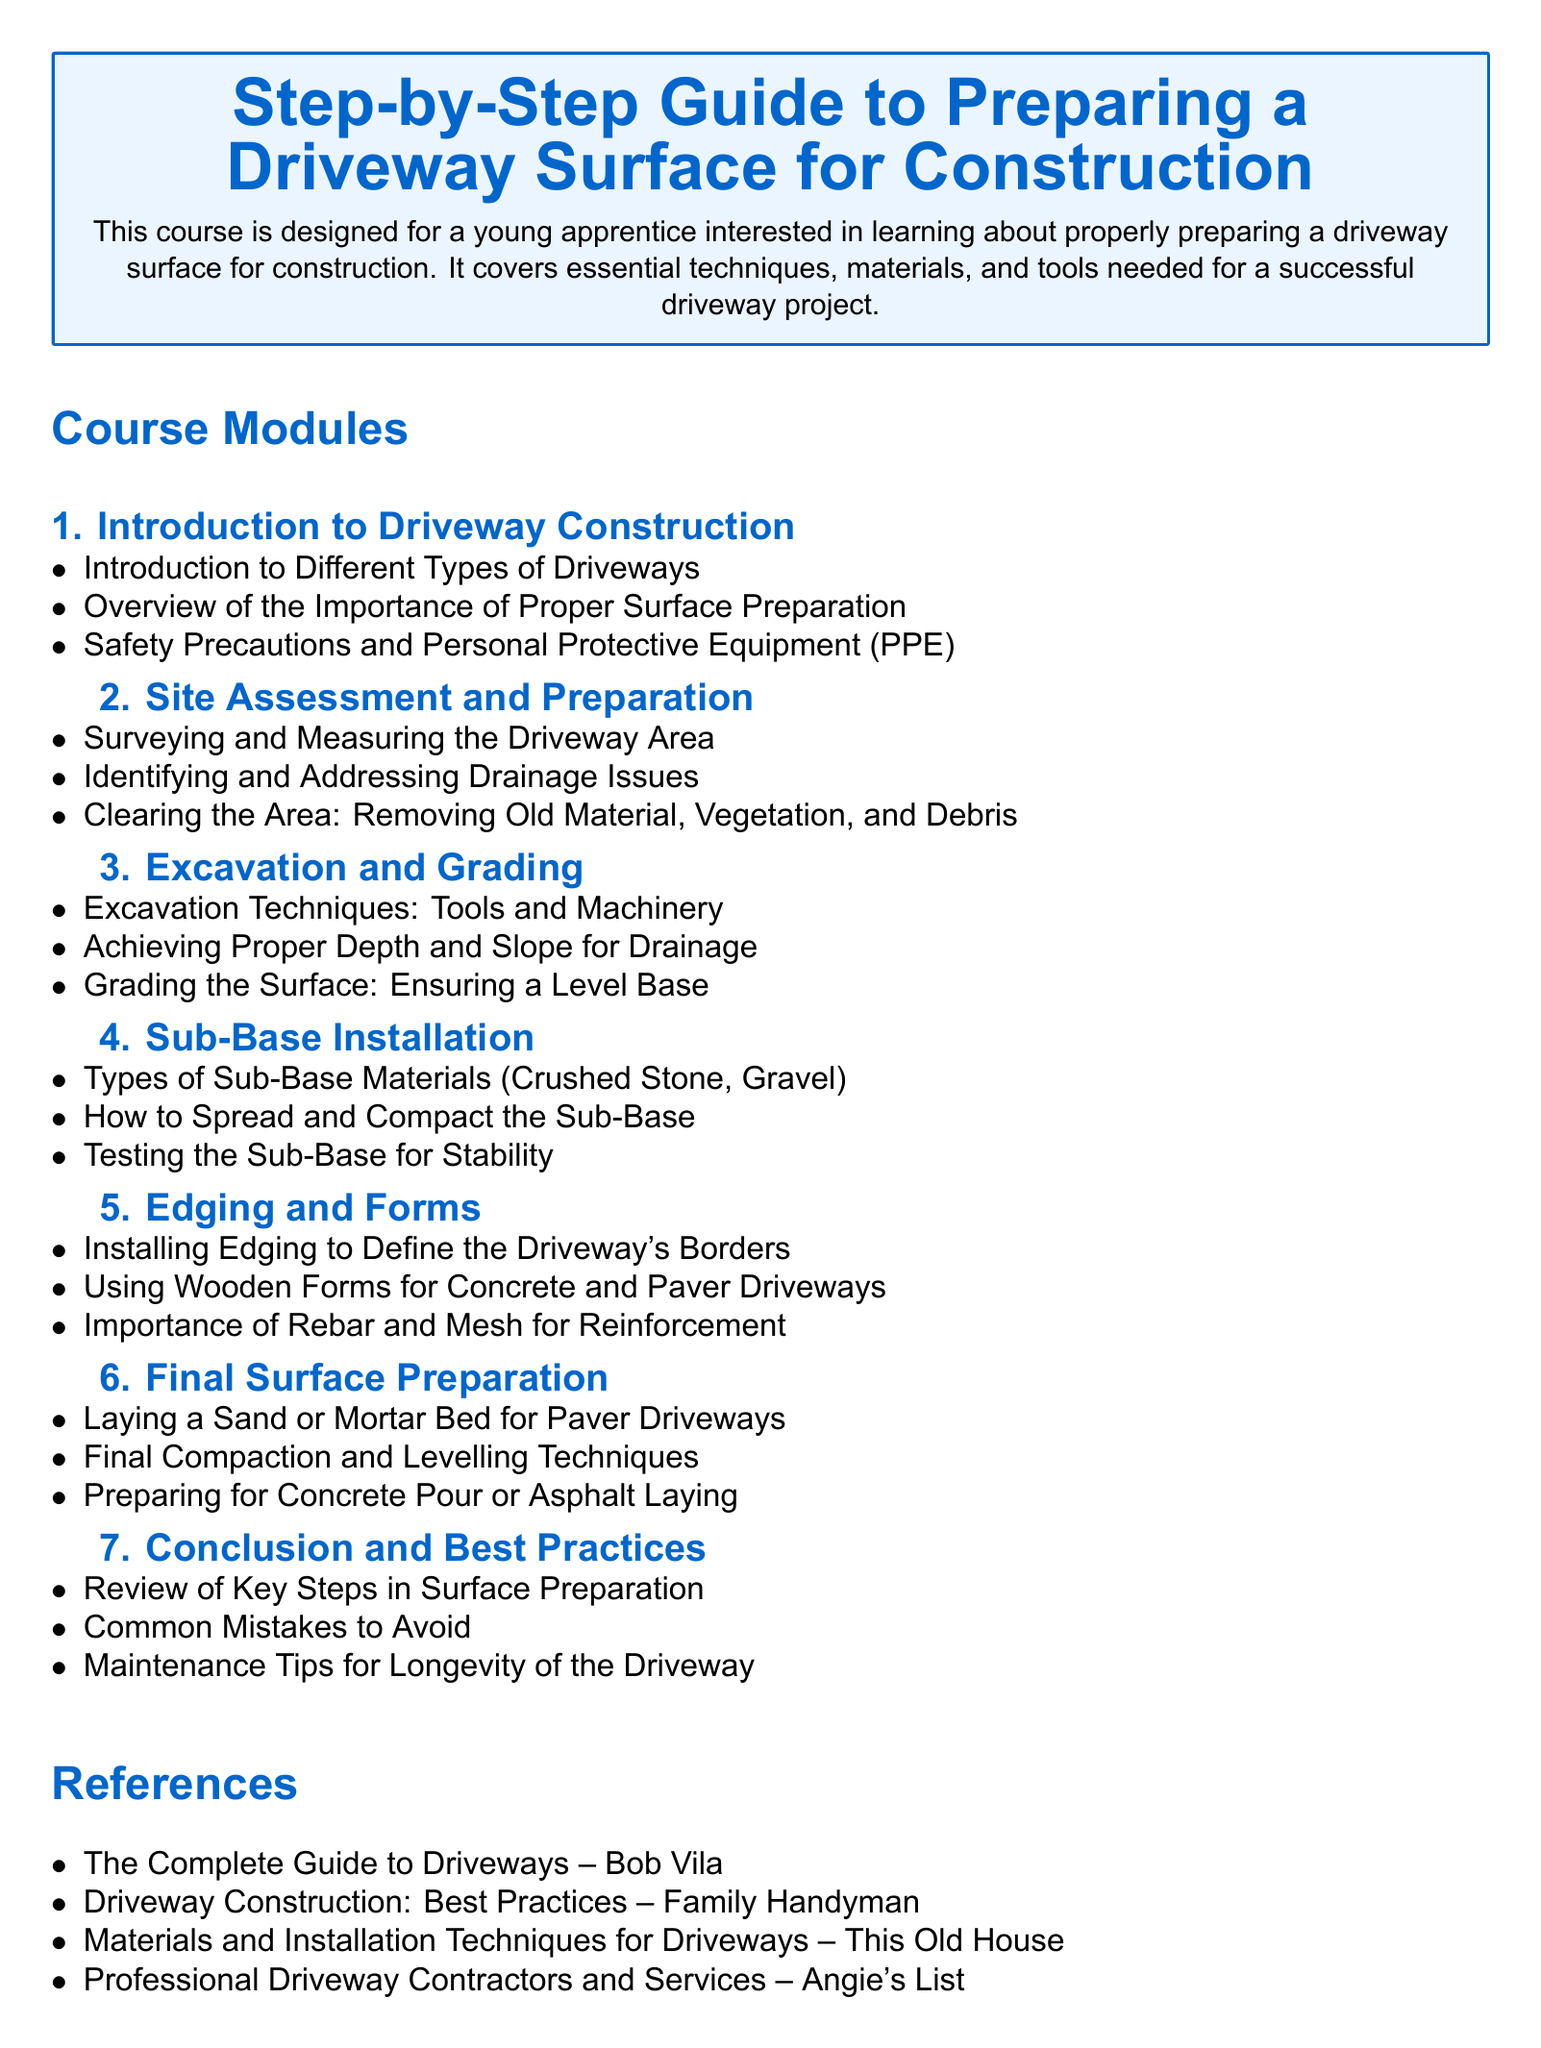What is the title of the document? The title is prominently displayed in a large font at the beginning of the document.
Answer: Step-by-Step Guide to Preparing a Driveway Surface for Construction How many modules are in the course? The modules are listed under the "Course Modules" section.
Answer: 7 What type of equipment is mentioned in the excavation techniques? Tools and machinery are specified as part of the excavation techniques.
Answer: Tools and machinery What is the focus of module 6? The content of module 6 is explicitly named to indicate its focus.
Answer: Final Surface Preparation Which material is used for the sub-base installation? The document specifies types of sub-base materials in the corresponding module.
Answer: Crushed Stone, Gravel What is a common mistake to avoid mentioned in the course? The common mistakes are noted in the last module discussing best practices.
Answer: Common Mistakes What should be done to ensure a level base? Achieving proper depth and slope for drainage implies an action to be taken to ensure a level base.
Answer: Grading the Surface What are the references provided at the end of the document? The references are cited in a list format under the "References" section.
Answer: The Complete Guide to Driveways – Bob Vila, Driveway Construction: Best Practices – Family Handyman, Materials and Installation Techniques for Driveways – This Old House, Professional Driveway Contractors and Services – Angie's List 